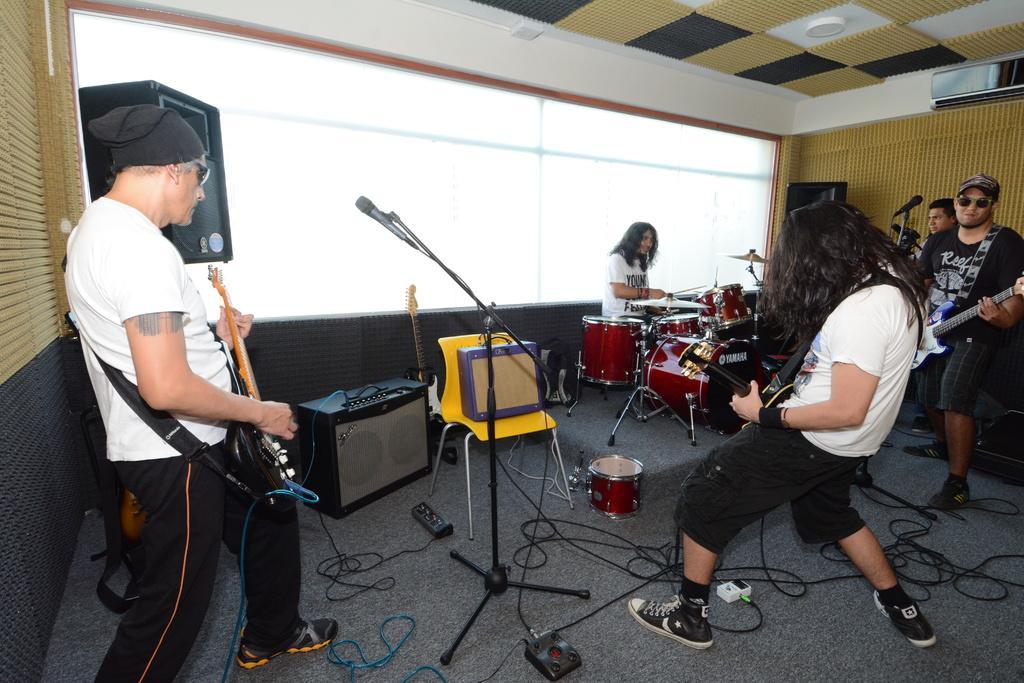Can you describe this image briefly? This is a picture of a group of people in the room who are playing some musical instruments and there is a speaker and mike and a air conditioner. 